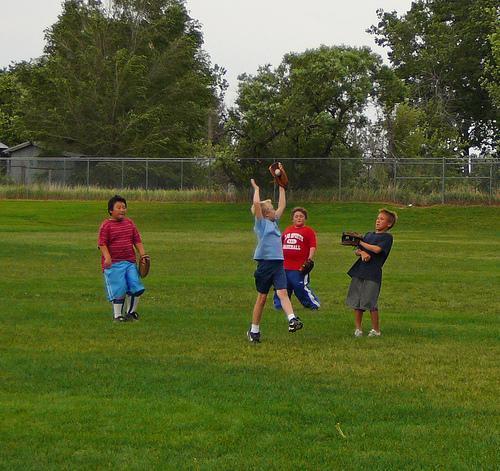How many people are there?
Give a very brief answer. 4. 